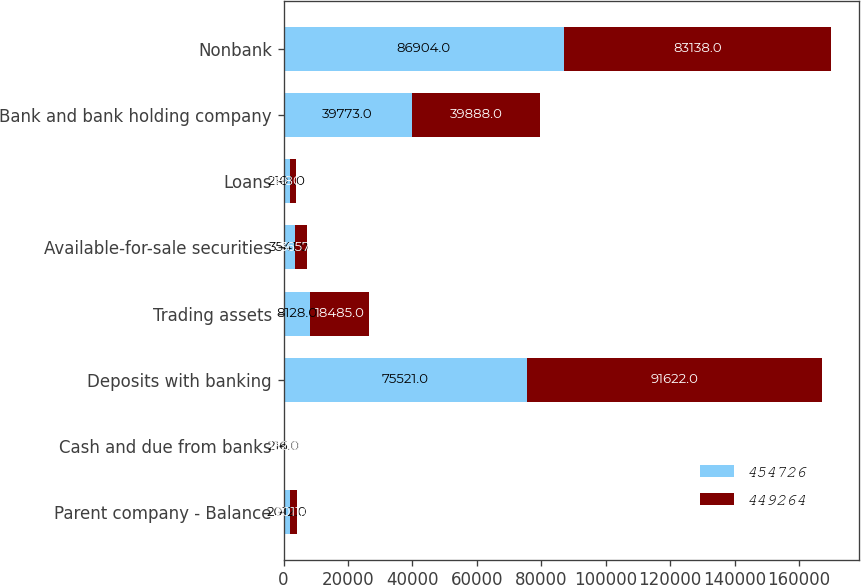Convert chart. <chart><loc_0><loc_0><loc_500><loc_500><stacked_bar_chart><ecel><fcel>Parent company - Balance<fcel>Cash and due from banks<fcel>Deposits with banking<fcel>Trading assets<fcel>Available-for-sale securities<fcel>Loans<fcel>Bank and bank holding company<fcel>Nonbank<nl><fcel>454726<fcel>2012<fcel>216<fcel>75521<fcel>8128<fcel>3541<fcel>2101<fcel>39773<fcel>86904<nl><fcel>449264<fcel>2011<fcel>132<fcel>91622<fcel>18485<fcel>3657<fcel>1880<fcel>39888<fcel>83138<nl></chart> 